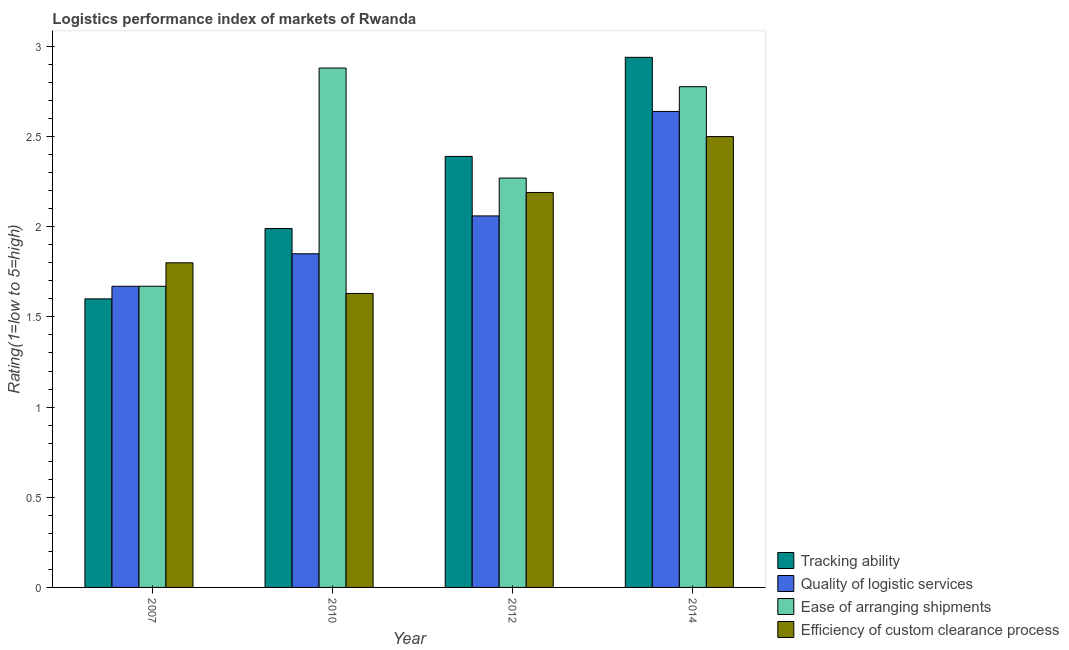How many different coloured bars are there?
Offer a very short reply. 4. How many groups of bars are there?
Offer a very short reply. 4. Are the number of bars per tick equal to the number of legend labels?
Offer a terse response. Yes. How many bars are there on the 1st tick from the left?
Provide a succinct answer. 4. How many bars are there on the 3rd tick from the right?
Offer a very short reply. 4. What is the lpi rating of ease of arranging shipments in 2014?
Your response must be concise. 2.78. Across all years, what is the minimum lpi rating of efficiency of custom clearance process?
Offer a very short reply. 1.63. In which year was the lpi rating of efficiency of custom clearance process minimum?
Offer a very short reply. 2010. What is the total lpi rating of quality of logistic services in the graph?
Offer a very short reply. 8.22. What is the difference between the lpi rating of ease of arranging shipments in 2010 and that in 2012?
Offer a very short reply. 0.61. What is the difference between the lpi rating of efficiency of custom clearance process in 2012 and the lpi rating of ease of arranging shipments in 2007?
Your answer should be compact. 0.39. What is the average lpi rating of ease of arranging shipments per year?
Your answer should be very brief. 2.4. In the year 2012, what is the difference between the lpi rating of efficiency of custom clearance process and lpi rating of quality of logistic services?
Offer a terse response. 0. What is the ratio of the lpi rating of efficiency of custom clearance process in 2007 to that in 2012?
Offer a very short reply. 0.82. Is the difference between the lpi rating of tracking ability in 2012 and 2014 greater than the difference between the lpi rating of efficiency of custom clearance process in 2012 and 2014?
Your answer should be compact. No. What is the difference between the highest and the second highest lpi rating of quality of logistic services?
Give a very brief answer. 0.58. What is the difference between the highest and the lowest lpi rating of quality of logistic services?
Provide a succinct answer. 0.97. In how many years, is the lpi rating of tracking ability greater than the average lpi rating of tracking ability taken over all years?
Your answer should be very brief. 2. Is it the case that in every year, the sum of the lpi rating of tracking ability and lpi rating of quality of logistic services is greater than the sum of lpi rating of efficiency of custom clearance process and lpi rating of ease of arranging shipments?
Give a very brief answer. No. What does the 2nd bar from the left in 2014 represents?
Provide a succinct answer. Quality of logistic services. What does the 2nd bar from the right in 2007 represents?
Your answer should be very brief. Ease of arranging shipments. Are the values on the major ticks of Y-axis written in scientific E-notation?
Offer a very short reply. No. Where does the legend appear in the graph?
Provide a short and direct response. Bottom right. What is the title of the graph?
Provide a short and direct response. Logistics performance index of markets of Rwanda. What is the label or title of the X-axis?
Offer a very short reply. Year. What is the label or title of the Y-axis?
Offer a terse response. Rating(1=low to 5=high). What is the Rating(1=low to 5=high) of Tracking ability in 2007?
Keep it short and to the point. 1.6. What is the Rating(1=low to 5=high) in Quality of logistic services in 2007?
Provide a short and direct response. 1.67. What is the Rating(1=low to 5=high) in Ease of arranging shipments in 2007?
Keep it short and to the point. 1.67. What is the Rating(1=low to 5=high) of Efficiency of custom clearance process in 2007?
Your response must be concise. 1.8. What is the Rating(1=low to 5=high) of Tracking ability in 2010?
Ensure brevity in your answer.  1.99. What is the Rating(1=low to 5=high) of Quality of logistic services in 2010?
Offer a terse response. 1.85. What is the Rating(1=low to 5=high) in Ease of arranging shipments in 2010?
Your answer should be very brief. 2.88. What is the Rating(1=low to 5=high) of Efficiency of custom clearance process in 2010?
Ensure brevity in your answer.  1.63. What is the Rating(1=low to 5=high) in Tracking ability in 2012?
Your answer should be very brief. 2.39. What is the Rating(1=low to 5=high) of Quality of logistic services in 2012?
Make the answer very short. 2.06. What is the Rating(1=low to 5=high) of Ease of arranging shipments in 2012?
Your answer should be compact. 2.27. What is the Rating(1=low to 5=high) of Efficiency of custom clearance process in 2012?
Your response must be concise. 2.19. What is the Rating(1=low to 5=high) of Tracking ability in 2014?
Keep it short and to the point. 2.94. What is the Rating(1=low to 5=high) of Quality of logistic services in 2014?
Keep it short and to the point. 2.64. What is the Rating(1=low to 5=high) of Ease of arranging shipments in 2014?
Provide a succinct answer. 2.78. Across all years, what is the maximum Rating(1=low to 5=high) in Tracking ability?
Your response must be concise. 2.94. Across all years, what is the maximum Rating(1=low to 5=high) in Quality of logistic services?
Your answer should be compact. 2.64. Across all years, what is the maximum Rating(1=low to 5=high) in Ease of arranging shipments?
Your response must be concise. 2.88. Across all years, what is the maximum Rating(1=low to 5=high) in Efficiency of custom clearance process?
Your response must be concise. 2.5. Across all years, what is the minimum Rating(1=low to 5=high) in Tracking ability?
Your answer should be very brief. 1.6. Across all years, what is the minimum Rating(1=low to 5=high) of Quality of logistic services?
Your answer should be compact. 1.67. Across all years, what is the minimum Rating(1=low to 5=high) in Ease of arranging shipments?
Keep it short and to the point. 1.67. Across all years, what is the minimum Rating(1=low to 5=high) in Efficiency of custom clearance process?
Your answer should be compact. 1.63. What is the total Rating(1=low to 5=high) of Tracking ability in the graph?
Provide a short and direct response. 8.92. What is the total Rating(1=low to 5=high) in Quality of logistic services in the graph?
Make the answer very short. 8.22. What is the total Rating(1=low to 5=high) of Ease of arranging shipments in the graph?
Offer a terse response. 9.6. What is the total Rating(1=low to 5=high) of Efficiency of custom clearance process in the graph?
Keep it short and to the point. 8.12. What is the difference between the Rating(1=low to 5=high) of Tracking ability in 2007 and that in 2010?
Your response must be concise. -0.39. What is the difference between the Rating(1=low to 5=high) of Quality of logistic services in 2007 and that in 2010?
Offer a terse response. -0.18. What is the difference between the Rating(1=low to 5=high) in Ease of arranging shipments in 2007 and that in 2010?
Offer a very short reply. -1.21. What is the difference between the Rating(1=low to 5=high) of Efficiency of custom clearance process in 2007 and that in 2010?
Provide a succinct answer. 0.17. What is the difference between the Rating(1=low to 5=high) of Tracking ability in 2007 and that in 2012?
Give a very brief answer. -0.79. What is the difference between the Rating(1=low to 5=high) of Quality of logistic services in 2007 and that in 2012?
Your answer should be very brief. -0.39. What is the difference between the Rating(1=low to 5=high) in Efficiency of custom clearance process in 2007 and that in 2012?
Your answer should be very brief. -0.39. What is the difference between the Rating(1=low to 5=high) in Tracking ability in 2007 and that in 2014?
Your answer should be compact. -1.34. What is the difference between the Rating(1=low to 5=high) of Quality of logistic services in 2007 and that in 2014?
Give a very brief answer. -0.97. What is the difference between the Rating(1=low to 5=high) of Ease of arranging shipments in 2007 and that in 2014?
Your answer should be very brief. -1.11. What is the difference between the Rating(1=low to 5=high) in Efficiency of custom clearance process in 2007 and that in 2014?
Provide a short and direct response. -0.7. What is the difference between the Rating(1=low to 5=high) in Tracking ability in 2010 and that in 2012?
Ensure brevity in your answer.  -0.4. What is the difference between the Rating(1=low to 5=high) of Quality of logistic services in 2010 and that in 2012?
Make the answer very short. -0.21. What is the difference between the Rating(1=low to 5=high) in Ease of arranging shipments in 2010 and that in 2012?
Your answer should be compact. 0.61. What is the difference between the Rating(1=low to 5=high) in Efficiency of custom clearance process in 2010 and that in 2012?
Provide a succinct answer. -0.56. What is the difference between the Rating(1=low to 5=high) in Tracking ability in 2010 and that in 2014?
Your answer should be compact. -0.95. What is the difference between the Rating(1=low to 5=high) in Quality of logistic services in 2010 and that in 2014?
Your answer should be compact. -0.79. What is the difference between the Rating(1=low to 5=high) of Ease of arranging shipments in 2010 and that in 2014?
Offer a terse response. 0.1. What is the difference between the Rating(1=low to 5=high) in Efficiency of custom clearance process in 2010 and that in 2014?
Provide a succinct answer. -0.87. What is the difference between the Rating(1=low to 5=high) of Tracking ability in 2012 and that in 2014?
Your answer should be compact. -0.55. What is the difference between the Rating(1=low to 5=high) in Quality of logistic services in 2012 and that in 2014?
Your response must be concise. -0.58. What is the difference between the Rating(1=low to 5=high) in Ease of arranging shipments in 2012 and that in 2014?
Your response must be concise. -0.51. What is the difference between the Rating(1=low to 5=high) of Efficiency of custom clearance process in 2012 and that in 2014?
Provide a succinct answer. -0.31. What is the difference between the Rating(1=low to 5=high) in Tracking ability in 2007 and the Rating(1=low to 5=high) in Ease of arranging shipments in 2010?
Provide a short and direct response. -1.28. What is the difference between the Rating(1=low to 5=high) of Tracking ability in 2007 and the Rating(1=low to 5=high) of Efficiency of custom clearance process in 2010?
Your response must be concise. -0.03. What is the difference between the Rating(1=low to 5=high) of Quality of logistic services in 2007 and the Rating(1=low to 5=high) of Ease of arranging shipments in 2010?
Offer a terse response. -1.21. What is the difference between the Rating(1=low to 5=high) in Tracking ability in 2007 and the Rating(1=low to 5=high) in Quality of logistic services in 2012?
Make the answer very short. -0.46. What is the difference between the Rating(1=low to 5=high) in Tracking ability in 2007 and the Rating(1=low to 5=high) in Ease of arranging shipments in 2012?
Offer a very short reply. -0.67. What is the difference between the Rating(1=low to 5=high) of Tracking ability in 2007 and the Rating(1=low to 5=high) of Efficiency of custom clearance process in 2012?
Give a very brief answer. -0.59. What is the difference between the Rating(1=low to 5=high) in Quality of logistic services in 2007 and the Rating(1=low to 5=high) in Efficiency of custom clearance process in 2012?
Give a very brief answer. -0.52. What is the difference between the Rating(1=low to 5=high) of Ease of arranging shipments in 2007 and the Rating(1=low to 5=high) of Efficiency of custom clearance process in 2012?
Your answer should be compact. -0.52. What is the difference between the Rating(1=low to 5=high) of Tracking ability in 2007 and the Rating(1=low to 5=high) of Quality of logistic services in 2014?
Offer a terse response. -1.04. What is the difference between the Rating(1=low to 5=high) in Tracking ability in 2007 and the Rating(1=low to 5=high) in Ease of arranging shipments in 2014?
Provide a succinct answer. -1.18. What is the difference between the Rating(1=low to 5=high) in Tracking ability in 2007 and the Rating(1=low to 5=high) in Efficiency of custom clearance process in 2014?
Ensure brevity in your answer.  -0.9. What is the difference between the Rating(1=low to 5=high) of Quality of logistic services in 2007 and the Rating(1=low to 5=high) of Ease of arranging shipments in 2014?
Keep it short and to the point. -1.11. What is the difference between the Rating(1=low to 5=high) of Quality of logistic services in 2007 and the Rating(1=low to 5=high) of Efficiency of custom clearance process in 2014?
Your response must be concise. -0.83. What is the difference between the Rating(1=low to 5=high) in Ease of arranging shipments in 2007 and the Rating(1=low to 5=high) in Efficiency of custom clearance process in 2014?
Your response must be concise. -0.83. What is the difference between the Rating(1=low to 5=high) in Tracking ability in 2010 and the Rating(1=low to 5=high) in Quality of logistic services in 2012?
Offer a terse response. -0.07. What is the difference between the Rating(1=low to 5=high) in Tracking ability in 2010 and the Rating(1=low to 5=high) in Ease of arranging shipments in 2012?
Ensure brevity in your answer.  -0.28. What is the difference between the Rating(1=low to 5=high) of Tracking ability in 2010 and the Rating(1=low to 5=high) of Efficiency of custom clearance process in 2012?
Give a very brief answer. -0.2. What is the difference between the Rating(1=low to 5=high) of Quality of logistic services in 2010 and the Rating(1=low to 5=high) of Ease of arranging shipments in 2012?
Provide a short and direct response. -0.42. What is the difference between the Rating(1=low to 5=high) in Quality of logistic services in 2010 and the Rating(1=low to 5=high) in Efficiency of custom clearance process in 2012?
Your response must be concise. -0.34. What is the difference between the Rating(1=low to 5=high) in Ease of arranging shipments in 2010 and the Rating(1=low to 5=high) in Efficiency of custom clearance process in 2012?
Make the answer very short. 0.69. What is the difference between the Rating(1=low to 5=high) of Tracking ability in 2010 and the Rating(1=low to 5=high) of Quality of logistic services in 2014?
Keep it short and to the point. -0.65. What is the difference between the Rating(1=low to 5=high) of Tracking ability in 2010 and the Rating(1=low to 5=high) of Ease of arranging shipments in 2014?
Give a very brief answer. -0.79. What is the difference between the Rating(1=low to 5=high) of Tracking ability in 2010 and the Rating(1=low to 5=high) of Efficiency of custom clearance process in 2014?
Ensure brevity in your answer.  -0.51. What is the difference between the Rating(1=low to 5=high) of Quality of logistic services in 2010 and the Rating(1=low to 5=high) of Ease of arranging shipments in 2014?
Provide a succinct answer. -0.93. What is the difference between the Rating(1=low to 5=high) of Quality of logistic services in 2010 and the Rating(1=low to 5=high) of Efficiency of custom clearance process in 2014?
Provide a succinct answer. -0.65. What is the difference between the Rating(1=low to 5=high) in Ease of arranging shipments in 2010 and the Rating(1=low to 5=high) in Efficiency of custom clearance process in 2014?
Offer a terse response. 0.38. What is the difference between the Rating(1=low to 5=high) of Tracking ability in 2012 and the Rating(1=low to 5=high) of Quality of logistic services in 2014?
Give a very brief answer. -0.25. What is the difference between the Rating(1=low to 5=high) of Tracking ability in 2012 and the Rating(1=low to 5=high) of Ease of arranging shipments in 2014?
Your response must be concise. -0.39. What is the difference between the Rating(1=low to 5=high) of Tracking ability in 2012 and the Rating(1=low to 5=high) of Efficiency of custom clearance process in 2014?
Give a very brief answer. -0.11. What is the difference between the Rating(1=low to 5=high) of Quality of logistic services in 2012 and the Rating(1=low to 5=high) of Ease of arranging shipments in 2014?
Offer a terse response. -0.72. What is the difference between the Rating(1=low to 5=high) in Quality of logistic services in 2012 and the Rating(1=low to 5=high) in Efficiency of custom clearance process in 2014?
Give a very brief answer. -0.44. What is the difference between the Rating(1=low to 5=high) of Ease of arranging shipments in 2012 and the Rating(1=low to 5=high) of Efficiency of custom clearance process in 2014?
Make the answer very short. -0.23. What is the average Rating(1=low to 5=high) in Tracking ability per year?
Your answer should be very brief. 2.23. What is the average Rating(1=low to 5=high) of Quality of logistic services per year?
Provide a succinct answer. 2.05. What is the average Rating(1=low to 5=high) in Ease of arranging shipments per year?
Your response must be concise. 2.4. What is the average Rating(1=low to 5=high) in Efficiency of custom clearance process per year?
Give a very brief answer. 2.03. In the year 2007, what is the difference between the Rating(1=low to 5=high) in Tracking ability and Rating(1=low to 5=high) in Quality of logistic services?
Your answer should be compact. -0.07. In the year 2007, what is the difference between the Rating(1=low to 5=high) in Tracking ability and Rating(1=low to 5=high) in Ease of arranging shipments?
Your response must be concise. -0.07. In the year 2007, what is the difference between the Rating(1=low to 5=high) of Quality of logistic services and Rating(1=low to 5=high) of Efficiency of custom clearance process?
Offer a very short reply. -0.13. In the year 2007, what is the difference between the Rating(1=low to 5=high) in Ease of arranging shipments and Rating(1=low to 5=high) in Efficiency of custom clearance process?
Your response must be concise. -0.13. In the year 2010, what is the difference between the Rating(1=low to 5=high) of Tracking ability and Rating(1=low to 5=high) of Quality of logistic services?
Offer a terse response. 0.14. In the year 2010, what is the difference between the Rating(1=low to 5=high) of Tracking ability and Rating(1=low to 5=high) of Ease of arranging shipments?
Provide a succinct answer. -0.89. In the year 2010, what is the difference between the Rating(1=low to 5=high) in Tracking ability and Rating(1=low to 5=high) in Efficiency of custom clearance process?
Offer a terse response. 0.36. In the year 2010, what is the difference between the Rating(1=low to 5=high) of Quality of logistic services and Rating(1=low to 5=high) of Ease of arranging shipments?
Keep it short and to the point. -1.03. In the year 2010, what is the difference between the Rating(1=low to 5=high) in Quality of logistic services and Rating(1=low to 5=high) in Efficiency of custom clearance process?
Offer a terse response. 0.22. In the year 2012, what is the difference between the Rating(1=low to 5=high) in Tracking ability and Rating(1=low to 5=high) in Quality of logistic services?
Provide a short and direct response. 0.33. In the year 2012, what is the difference between the Rating(1=low to 5=high) of Tracking ability and Rating(1=low to 5=high) of Ease of arranging shipments?
Offer a very short reply. 0.12. In the year 2012, what is the difference between the Rating(1=low to 5=high) in Tracking ability and Rating(1=low to 5=high) in Efficiency of custom clearance process?
Keep it short and to the point. 0.2. In the year 2012, what is the difference between the Rating(1=low to 5=high) of Quality of logistic services and Rating(1=low to 5=high) of Ease of arranging shipments?
Offer a terse response. -0.21. In the year 2012, what is the difference between the Rating(1=low to 5=high) of Quality of logistic services and Rating(1=low to 5=high) of Efficiency of custom clearance process?
Make the answer very short. -0.13. In the year 2014, what is the difference between the Rating(1=low to 5=high) in Tracking ability and Rating(1=low to 5=high) in Quality of logistic services?
Ensure brevity in your answer.  0.3. In the year 2014, what is the difference between the Rating(1=low to 5=high) of Tracking ability and Rating(1=low to 5=high) of Ease of arranging shipments?
Keep it short and to the point. 0.16. In the year 2014, what is the difference between the Rating(1=low to 5=high) of Tracking ability and Rating(1=low to 5=high) of Efficiency of custom clearance process?
Keep it short and to the point. 0.44. In the year 2014, what is the difference between the Rating(1=low to 5=high) in Quality of logistic services and Rating(1=low to 5=high) in Ease of arranging shipments?
Provide a succinct answer. -0.14. In the year 2014, what is the difference between the Rating(1=low to 5=high) of Quality of logistic services and Rating(1=low to 5=high) of Efficiency of custom clearance process?
Offer a terse response. 0.14. In the year 2014, what is the difference between the Rating(1=low to 5=high) in Ease of arranging shipments and Rating(1=low to 5=high) in Efficiency of custom clearance process?
Offer a terse response. 0.28. What is the ratio of the Rating(1=low to 5=high) in Tracking ability in 2007 to that in 2010?
Your answer should be very brief. 0.8. What is the ratio of the Rating(1=low to 5=high) of Quality of logistic services in 2007 to that in 2010?
Keep it short and to the point. 0.9. What is the ratio of the Rating(1=low to 5=high) of Ease of arranging shipments in 2007 to that in 2010?
Offer a terse response. 0.58. What is the ratio of the Rating(1=low to 5=high) in Efficiency of custom clearance process in 2007 to that in 2010?
Give a very brief answer. 1.1. What is the ratio of the Rating(1=low to 5=high) in Tracking ability in 2007 to that in 2012?
Offer a very short reply. 0.67. What is the ratio of the Rating(1=low to 5=high) of Quality of logistic services in 2007 to that in 2012?
Your answer should be very brief. 0.81. What is the ratio of the Rating(1=low to 5=high) in Ease of arranging shipments in 2007 to that in 2012?
Your answer should be very brief. 0.74. What is the ratio of the Rating(1=low to 5=high) in Efficiency of custom clearance process in 2007 to that in 2012?
Your answer should be compact. 0.82. What is the ratio of the Rating(1=low to 5=high) of Tracking ability in 2007 to that in 2014?
Your response must be concise. 0.54. What is the ratio of the Rating(1=low to 5=high) in Quality of logistic services in 2007 to that in 2014?
Offer a very short reply. 0.63. What is the ratio of the Rating(1=low to 5=high) in Ease of arranging shipments in 2007 to that in 2014?
Your answer should be compact. 0.6. What is the ratio of the Rating(1=low to 5=high) in Efficiency of custom clearance process in 2007 to that in 2014?
Provide a short and direct response. 0.72. What is the ratio of the Rating(1=low to 5=high) of Tracking ability in 2010 to that in 2012?
Provide a short and direct response. 0.83. What is the ratio of the Rating(1=low to 5=high) in Quality of logistic services in 2010 to that in 2012?
Provide a short and direct response. 0.9. What is the ratio of the Rating(1=low to 5=high) in Ease of arranging shipments in 2010 to that in 2012?
Give a very brief answer. 1.27. What is the ratio of the Rating(1=low to 5=high) in Efficiency of custom clearance process in 2010 to that in 2012?
Offer a very short reply. 0.74. What is the ratio of the Rating(1=low to 5=high) of Tracking ability in 2010 to that in 2014?
Keep it short and to the point. 0.68. What is the ratio of the Rating(1=low to 5=high) in Quality of logistic services in 2010 to that in 2014?
Ensure brevity in your answer.  0.7. What is the ratio of the Rating(1=low to 5=high) in Ease of arranging shipments in 2010 to that in 2014?
Ensure brevity in your answer.  1.04. What is the ratio of the Rating(1=low to 5=high) of Efficiency of custom clearance process in 2010 to that in 2014?
Offer a very short reply. 0.65. What is the ratio of the Rating(1=low to 5=high) in Tracking ability in 2012 to that in 2014?
Ensure brevity in your answer.  0.81. What is the ratio of the Rating(1=low to 5=high) of Quality of logistic services in 2012 to that in 2014?
Your answer should be very brief. 0.78. What is the ratio of the Rating(1=low to 5=high) in Ease of arranging shipments in 2012 to that in 2014?
Provide a short and direct response. 0.82. What is the ratio of the Rating(1=low to 5=high) in Efficiency of custom clearance process in 2012 to that in 2014?
Keep it short and to the point. 0.88. What is the difference between the highest and the second highest Rating(1=low to 5=high) of Tracking ability?
Offer a terse response. 0.55. What is the difference between the highest and the second highest Rating(1=low to 5=high) of Quality of logistic services?
Offer a very short reply. 0.58. What is the difference between the highest and the second highest Rating(1=low to 5=high) of Ease of arranging shipments?
Provide a short and direct response. 0.1. What is the difference between the highest and the second highest Rating(1=low to 5=high) of Efficiency of custom clearance process?
Give a very brief answer. 0.31. What is the difference between the highest and the lowest Rating(1=low to 5=high) of Tracking ability?
Provide a succinct answer. 1.34. What is the difference between the highest and the lowest Rating(1=low to 5=high) in Quality of logistic services?
Offer a very short reply. 0.97. What is the difference between the highest and the lowest Rating(1=low to 5=high) in Ease of arranging shipments?
Your answer should be very brief. 1.21. What is the difference between the highest and the lowest Rating(1=low to 5=high) of Efficiency of custom clearance process?
Give a very brief answer. 0.87. 